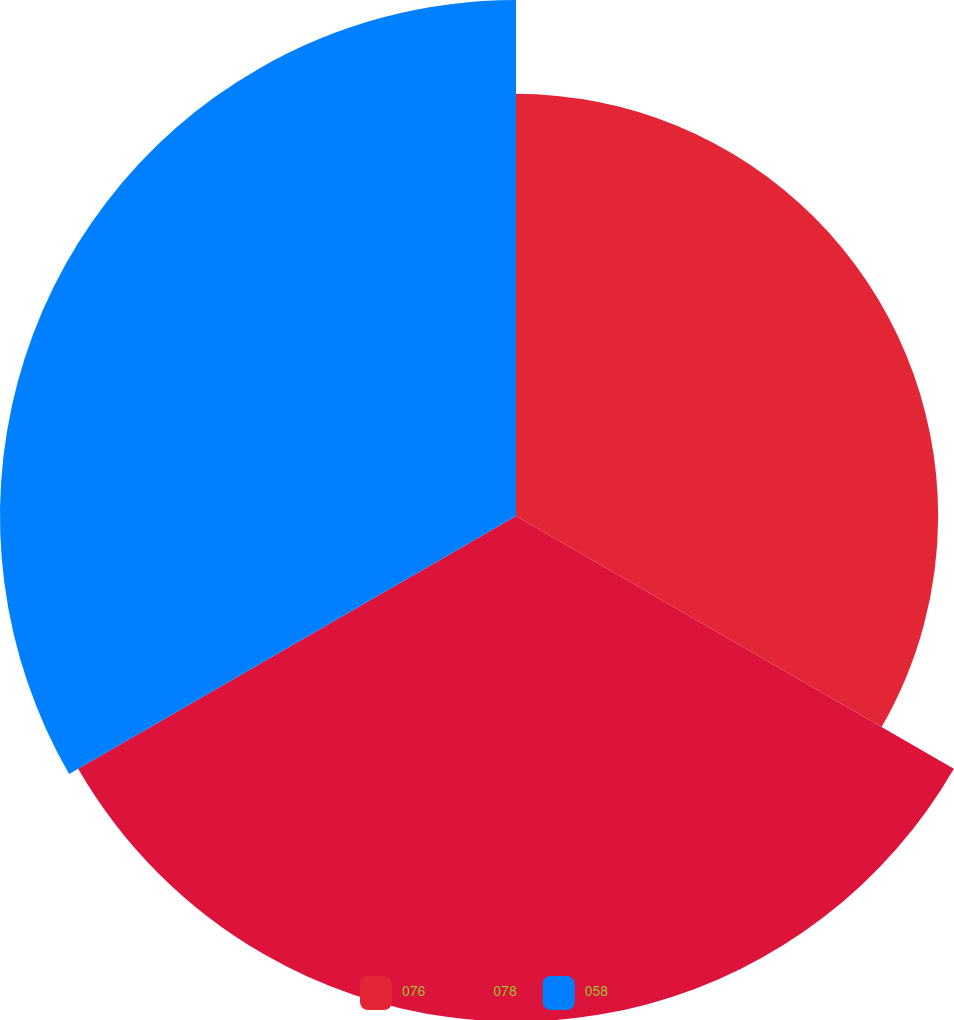<chart> <loc_0><loc_0><loc_500><loc_500><pie_chart><fcel>076<fcel>078<fcel>058<nl><fcel>29.24%<fcel>35.02%<fcel>35.74%<nl></chart> 